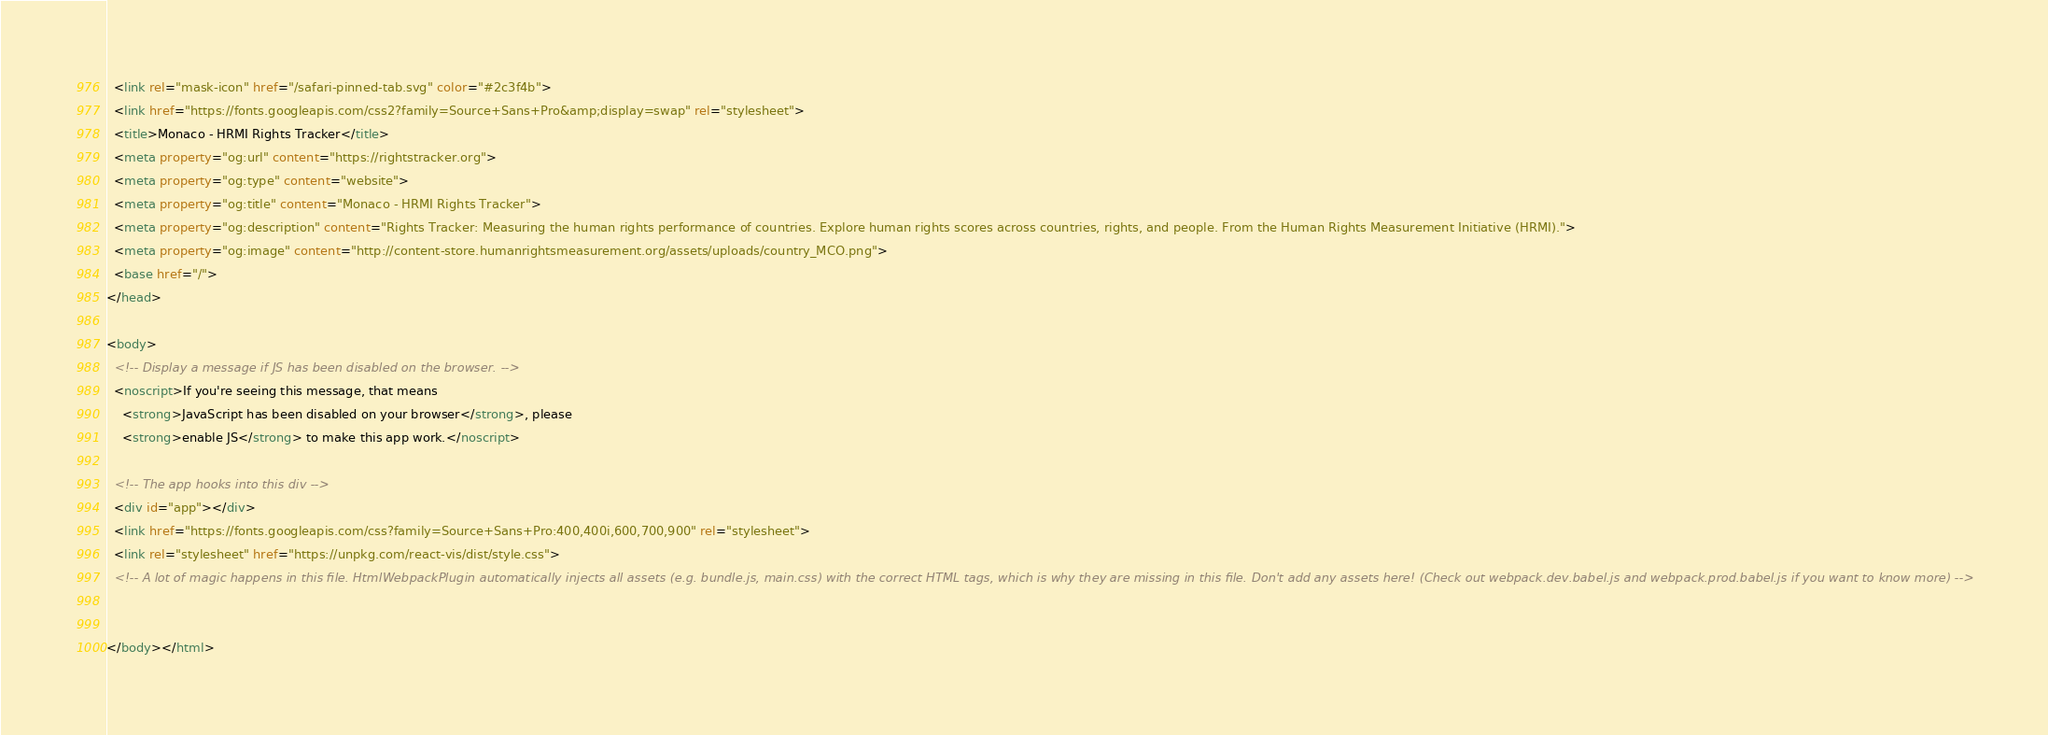<code> <loc_0><loc_0><loc_500><loc_500><_HTML_>  <link rel="mask-icon" href="/safari-pinned-tab.svg" color="#2c3f4b">
  <link href="https://fonts.googleapis.com/css2?family=Source+Sans+Pro&amp;display=swap" rel="stylesheet">
  <title>Monaco - HRMI Rights Tracker</title>
  <meta property="og:url" content="https://rightstracker.org">
  <meta property="og:type" content="website">
  <meta property="og:title" content="Monaco - HRMI Rights Tracker">
  <meta property="og:description" content="Rights Tracker: Measuring the human rights performance of countries. Explore human rights scores across countries, rights, and people. From the Human Rights Measurement Initiative (HRMI).">
  <meta property="og:image" content="http://content-store.humanrightsmeasurement.org/assets/uploads/country_MCO.png">
  <base href="/">
</head>

<body>
  <!-- Display a message if JS has been disabled on the browser. -->
  <noscript>If you're seeing this message, that means
    <strong>JavaScript has been disabled on your browser</strong>, please
    <strong>enable JS</strong> to make this app work.</noscript>

  <!-- The app hooks into this div -->
  <div id="app"></div>
  <link href="https://fonts.googleapis.com/css?family=Source+Sans+Pro:400,400i,600,700,900" rel="stylesheet">
  <link rel="stylesheet" href="https://unpkg.com/react-vis/dist/style.css">
  <!-- A lot of magic happens in this file. HtmlWebpackPlugin automatically injects all assets (e.g. bundle.js, main.css) with the correct HTML tags, which is why they are missing in this file. Don't add any assets here! (Check out webpack.dev.babel.js and webpack.prod.babel.js if you want to know more) -->


</body></html></code> 